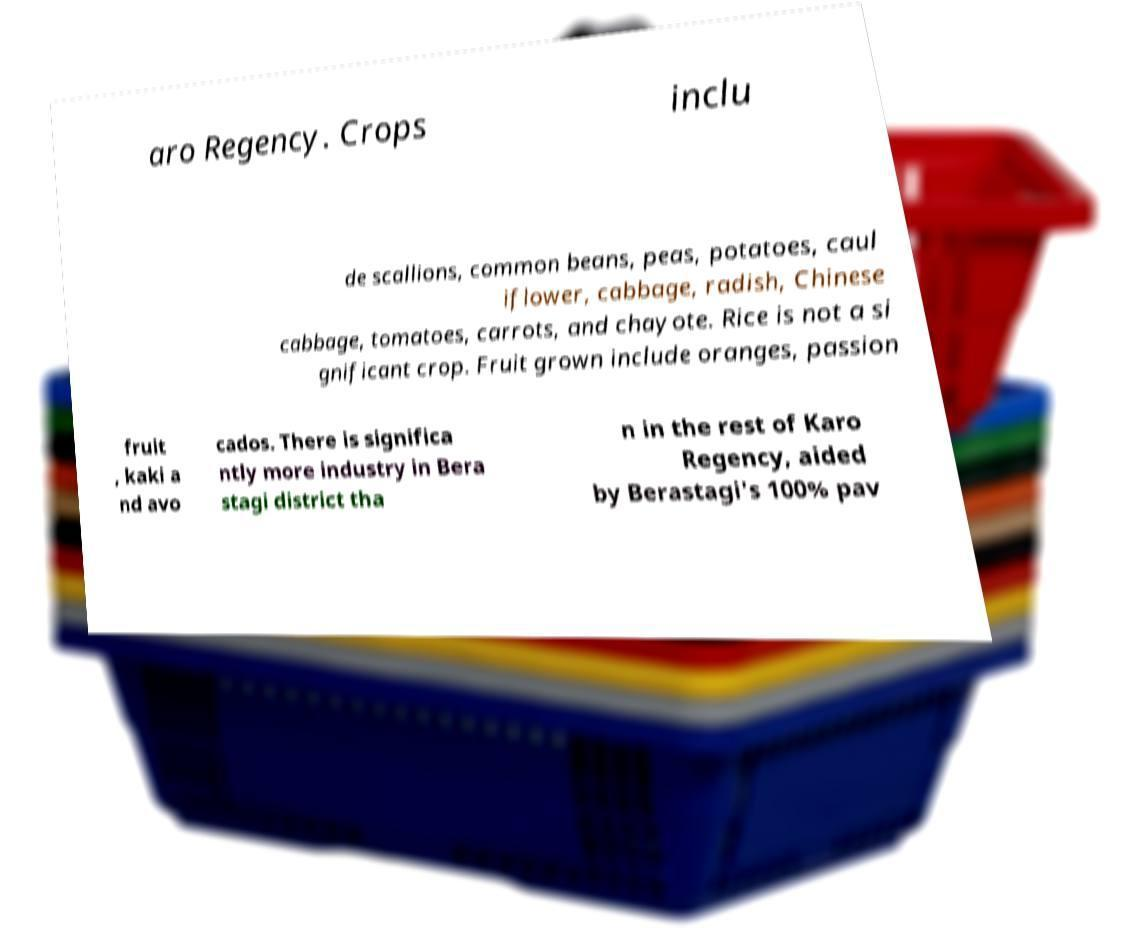Can you accurately transcribe the text from the provided image for me? aro Regency. Crops inclu de scallions, common beans, peas, potatoes, caul iflower, cabbage, radish, Chinese cabbage, tomatoes, carrots, and chayote. Rice is not a si gnificant crop. Fruit grown include oranges, passion fruit , kaki a nd avo cados. There is significa ntly more industry in Bera stagi district tha n in the rest of Karo Regency, aided by Berastagi's 100% pav 